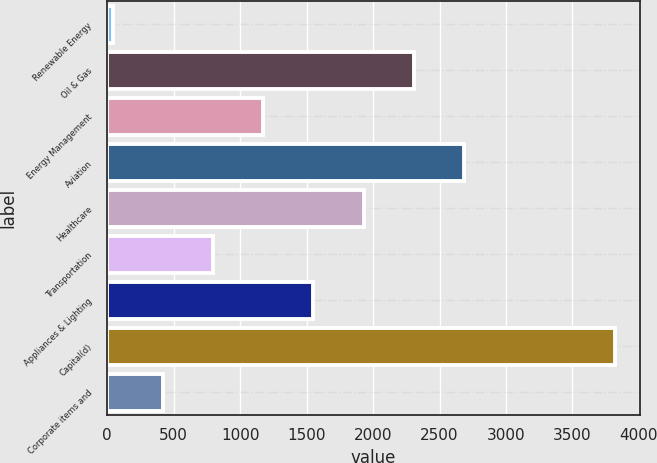Convert chart to OTSL. <chart><loc_0><loc_0><loc_500><loc_500><bar_chart><fcel>Renewable Energy<fcel>Oil & Gas<fcel>Energy Management<fcel>Aviation<fcel>Healthcare<fcel>Transportation<fcel>Appliances & Lighting<fcel>Capital(d)<fcel>Corporate items and<nl><fcel>41<fcel>2307.2<fcel>1174.1<fcel>2684.9<fcel>1929.5<fcel>796.4<fcel>1551.8<fcel>3818<fcel>418.7<nl></chart> 